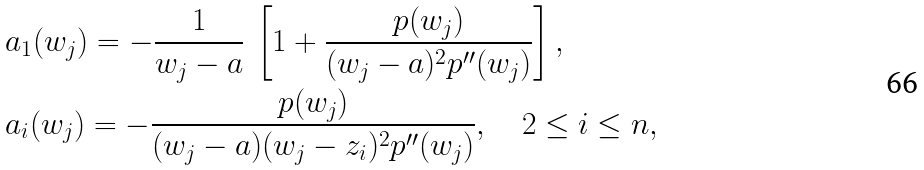Convert formula to latex. <formula><loc_0><loc_0><loc_500><loc_500>& a _ { 1 } ( w _ { j } ) = - \frac { 1 } { w _ { j } - a } \, \left [ 1 + \frac { p ( w _ { j } ) } { ( w _ { j } - a ) ^ { 2 } p ^ { \prime \prime } ( w _ { j } ) } \right ] , \\ & a _ { i } ( w _ { j } ) = - \frac { p ( w _ { j } ) } { ( w _ { j } - a ) ( w _ { j } - z _ { i } ) ^ { 2 } p ^ { \prime \prime } ( w _ { j } ) } , \quad 2 \leq i \leq n ,</formula> 